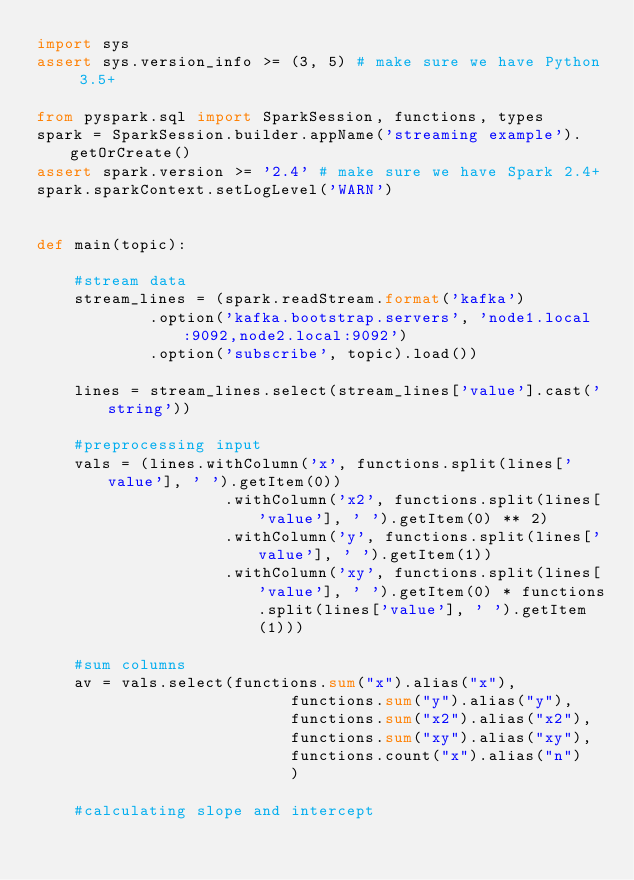Convert code to text. <code><loc_0><loc_0><loc_500><loc_500><_Python_>import sys
assert sys.version_info >= (3, 5) # make sure we have Python 3.5+

from pyspark.sql import SparkSession, functions, types
spark = SparkSession.builder.appName('streaming example').getOrCreate()
assert spark.version >= '2.4' # make sure we have Spark 2.4+
spark.sparkContext.setLogLevel('WARN')


def main(topic):

    #stream data
    stream_lines = (spark.readStream.format('kafka')
            .option('kafka.bootstrap.servers', 'node1.local:9092,node2.local:9092')
            .option('subscribe', topic).load())

    lines = stream_lines.select(stream_lines['value'].cast('string'))

    #preprocessing input
    vals = (lines.withColumn('x', functions.split(lines['value'], ' ').getItem(0))
                    .withColumn('x2', functions.split(lines['value'], ' ').getItem(0) ** 2)
                    .withColumn('y', functions.split(lines['value'], ' ').getItem(1))
                    .withColumn('xy', functions.split(lines['value'], ' ').getItem(0) * functions.split(lines['value'], ' ').getItem(1)))

    #sum columns
    av = vals.select(functions.sum("x").alias("x"), 
                           functions.sum("y").alias("y"), 
                           functions.sum("x2").alias("x2"), 
                           functions.sum("xy").alias("xy"),
                           functions.count("x").alias("n")
                           )

    #calculating slope and intercept</code> 